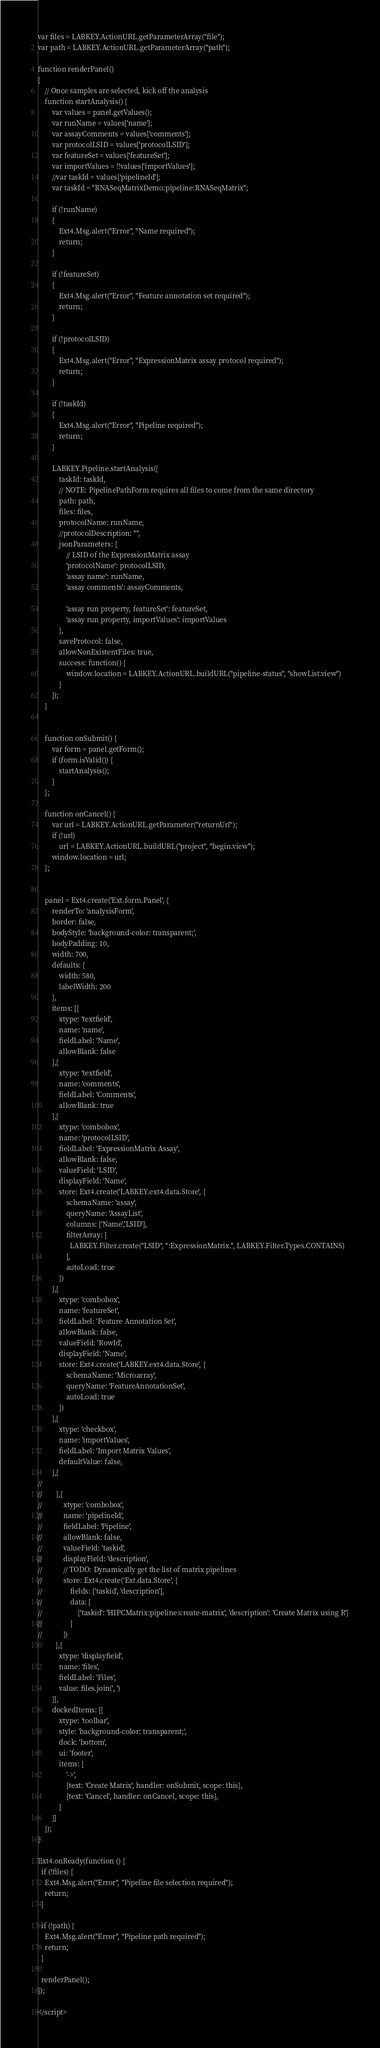Convert code to text. <code><loc_0><loc_0><loc_500><loc_500><_HTML_>var files = LABKEY.ActionURL.getParameterArray("file");
var path = LABKEY.ActionURL.getParameterArray("path");

function renderPanel()
{
    // Once samples are selected, kick off the analysis
    function startAnalysis() {
        var values = panel.getValues();
        var runName = values['name'];
        var assayComments = values['comments'];
        var protocolLSID = values['protocolLSID'];
        var featureSet = values['featureSet'];
        var importValues = !!values['importValues'];
        //var taskId = values['pipelineId'];
        var taskId = "RNASeqMatrixDemo:pipeline:RNASeqMatrix";

        if (!runName)
        {
            Ext4.Msg.alert("Error", "Name required");
            return;
        }

        if (!featureSet)
        {
            Ext4.Msg.alert("Error", "Feature annotation set required");
            return;
        }

        if (!protocolLSID)
        {
            Ext4.Msg.alert("Error", "ExpressionMatrix assay protocol required");
            return;
        }

        if (!taskId)
        {
            Ext4.Msg.alert("Error", "Pipeline required");
            return;
        }

        LABKEY.Pipeline.startAnalysis({
            taskId: taskId,
            // NOTE: PipelinePathForm requires all files to come from the same directory
            path: path,
            files: files,
            protocolName: runName,
            //protocolDescription: "",
            jsonParameters: {
                // LSID of the ExpressionMatrix assay
                'protocolName': protocolLSID,
                'assay name': runName,
                'assay comments': assayComments,

                'assay run property, featureSet': featureSet,
                'assay run property, importValues': importValues
            },
            saveProtocol: false,
            allowNonExistentFiles: true,
            success: function() {
                window.location = LABKEY.ActionURL.buildURL("pipeline-status", "showList.view")
            }
        });
    }


    function onSubmit() {
        var form = panel.getForm();
        if (form.isValid()) {
            startAnalysis();
        }
    };

    function onCancel() {
        var url = LABKEY.ActionURL.getParameter("returnUrl");
        if (!url)
            url = LABKEY.ActionURL.buildURL("project", "begin.view");
        window.location = url;
    };


    panel = Ext4.create('Ext.form.Panel', {
        renderTo: 'analysisForm',
        border: false,
        bodyStyle: 'background-color: transparent;',
        bodyPadding: 10,
        width: 700,
        defaults: {
            width: 580,
            labelWidth: 200
        },
        items: [{
            xtype: 'textfield',
            name: 'name',
            fieldLabel: 'Name',
            allowBlank: false
        },{
            xtype: 'textfield',
            name: 'comments',
            fieldLabel: 'Comments',
            allowBlank: true
        },{
            xtype: 'combobox',
            name: 'protocolLSID',
            fieldLabel: 'ExpressionMatrix Assay',
            allowBlank: false,
            valueField: 'LSID',
            displayField: 'Name',
            store: Ext4.create('LABKEY.ext4.data.Store', {
                schemaName: 'assay',
                queryName: 'AssayList',
                columns: ['Name','LSID'],
                filterArray: [
                  LABKEY.Filter.create("LSID", ":ExpressionMatrix.", LABKEY.Filter.Types.CONTAINS)
                ],
                autoLoad: true
            })
        },{
            xtype: 'combobox',
            name: 'featureSet',
            fieldLabel: 'Feature Annotation Set',
            allowBlank: false,
            valueField: 'RowId',
            displayField: 'Name',
            store: Ext4.create('LABKEY.ext4.data.Store', {
                schemaName: 'Microarray',
                queryName: 'FeatureAnnotationSet',
                autoLoad: true
            })
        },{
            xtype: 'checkbox',
            name: 'importValues',
            fieldLabel: 'Import Matrix Values',
            defaultValue: false,
        },{
//
//        },{
//            xtype: 'combobox',
//            name: 'pipelineId',
//            fieldLabel: 'Pipeline',
//            allowBlank: false,
//            valueField: 'taskid',
//            displayField: 'description',
//            // TODO: Dynamically get the list of matrix pipelines
//            store: Ext4.create('Ext.data.Store', {
//                fields: ['taskid', 'description'],
//                data: [
//                    {'taskid': 'HIPCMatrix:pipeline:create-matrix', 'description': 'Create Matrix using R'}
//                ]
//            })
          },{
            xtype: 'displayfield',
            name: 'files',
            fieldLabel: 'Files',
            value: files.join(', ')
        }],
        dockedItems: [{
            xtype: 'toolbar',
            style: 'background-color: transparent;',
            dock: 'bottom',
            ui: 'footer',
            items: [
                '->',
                {text: 'Create Matrix', handler: onSubmit, scope: this},
                {text: 'Cancel', handler: onCancel, scope: this},
            ]
        }]
    });
}

Ext4.onReady(function () {
  if (!files) {
    Ext4.Msg.alert("Error", "Pipeline file selection required");
    return;
  }

  if (!path) {
    Ext4.Msg.alert("Error", "Pipeline path required");
    return;
  }

  renderPanel();
});

</script>


</code> 